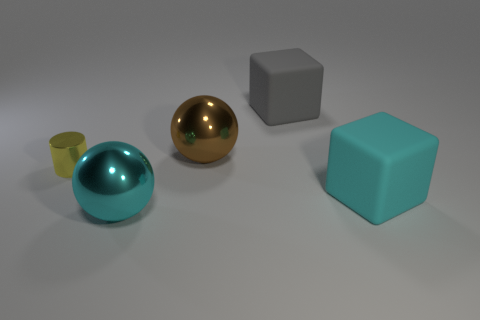Subtract all cyan blocks. How many blocks are left? 1 Add 5 cylinders. How many objects exist? 10 Subtract all brown balls. Subtract all yellow blocks. How many balls are left? 1 Subtract all purple balls. How many cyan cylinders are left? 0 Subtract all matte blocks. Subtract all cylinders. How many objects are left? 2 Add 5 small cylinders. How many small cylinders are left? 6 Add 1 tiny metallic cylinders. How many tiny metallic cylinders exist? 2 Subtract 1 yellow cylinders. How many objects are left? 4 Subtract all balls. How many objects are left? 3 Subtract 2 cubes. How many cubes are left? 0 